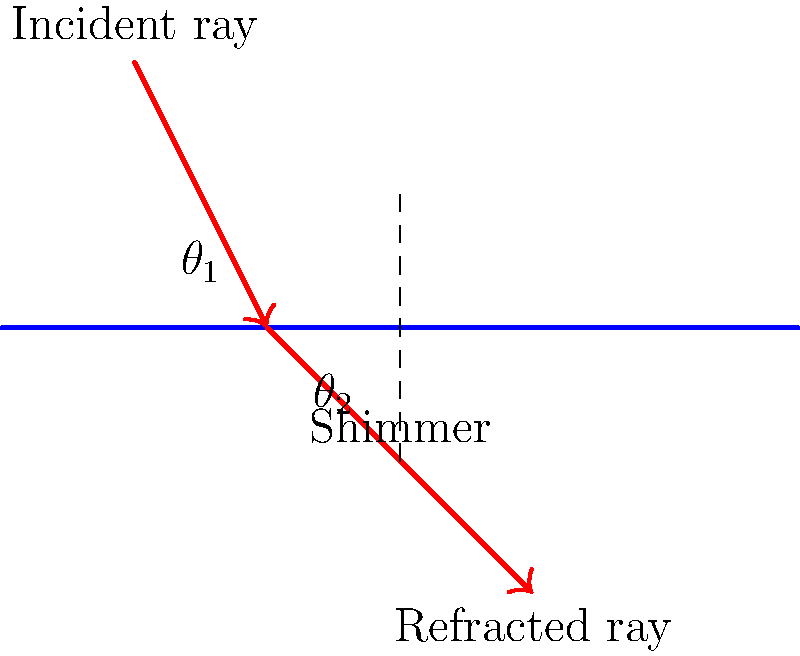In the movie "Annihilation," the shimmer exhibits unique light refraction properties. Based on the diagram, if the angle of incidence ($\theta_1$) is 45°, and the refraction index of the shimmer is 1.5 relative to air, what is the angle of refraction ($\theta_2$) to the nearest degree? To solve this problem, we'll use Snell's law, which describes the relationship between the angles of incidence and refraction when light passes through different media:

1) Snell's law: $n_1 \sin(\theta_1) = n_2 \sin(\theta_2)$

2) Given:
   - $n_1$ (air) = 1
   - $n_2$ (shimmer) = 1.5
   - $\theta_1 = 45°$

3) Substitute these values into Snell's law:
   $1 \sin(45°) = 1.5 \sin(\theta_2)$

4) Simplify:
   $\sin(45°) = 1.5 \sin(\theta_2)$

5) Solve for $\sin(\theta_2)$:
   $\sin(\theta_2) = \frac{\sin(45°)}{1.5} = \frac{1/\sqrt{2}}{1.5} \approx 0.4714$

6) Take the inverse sine (arcsin) of both sides:
   $\theta_2 = \arcsin(0.4714) \approx 28.1°$

7) Rounding to the nearest degree:
   $\theta_2 \approx 28°$
Answer: 28° 